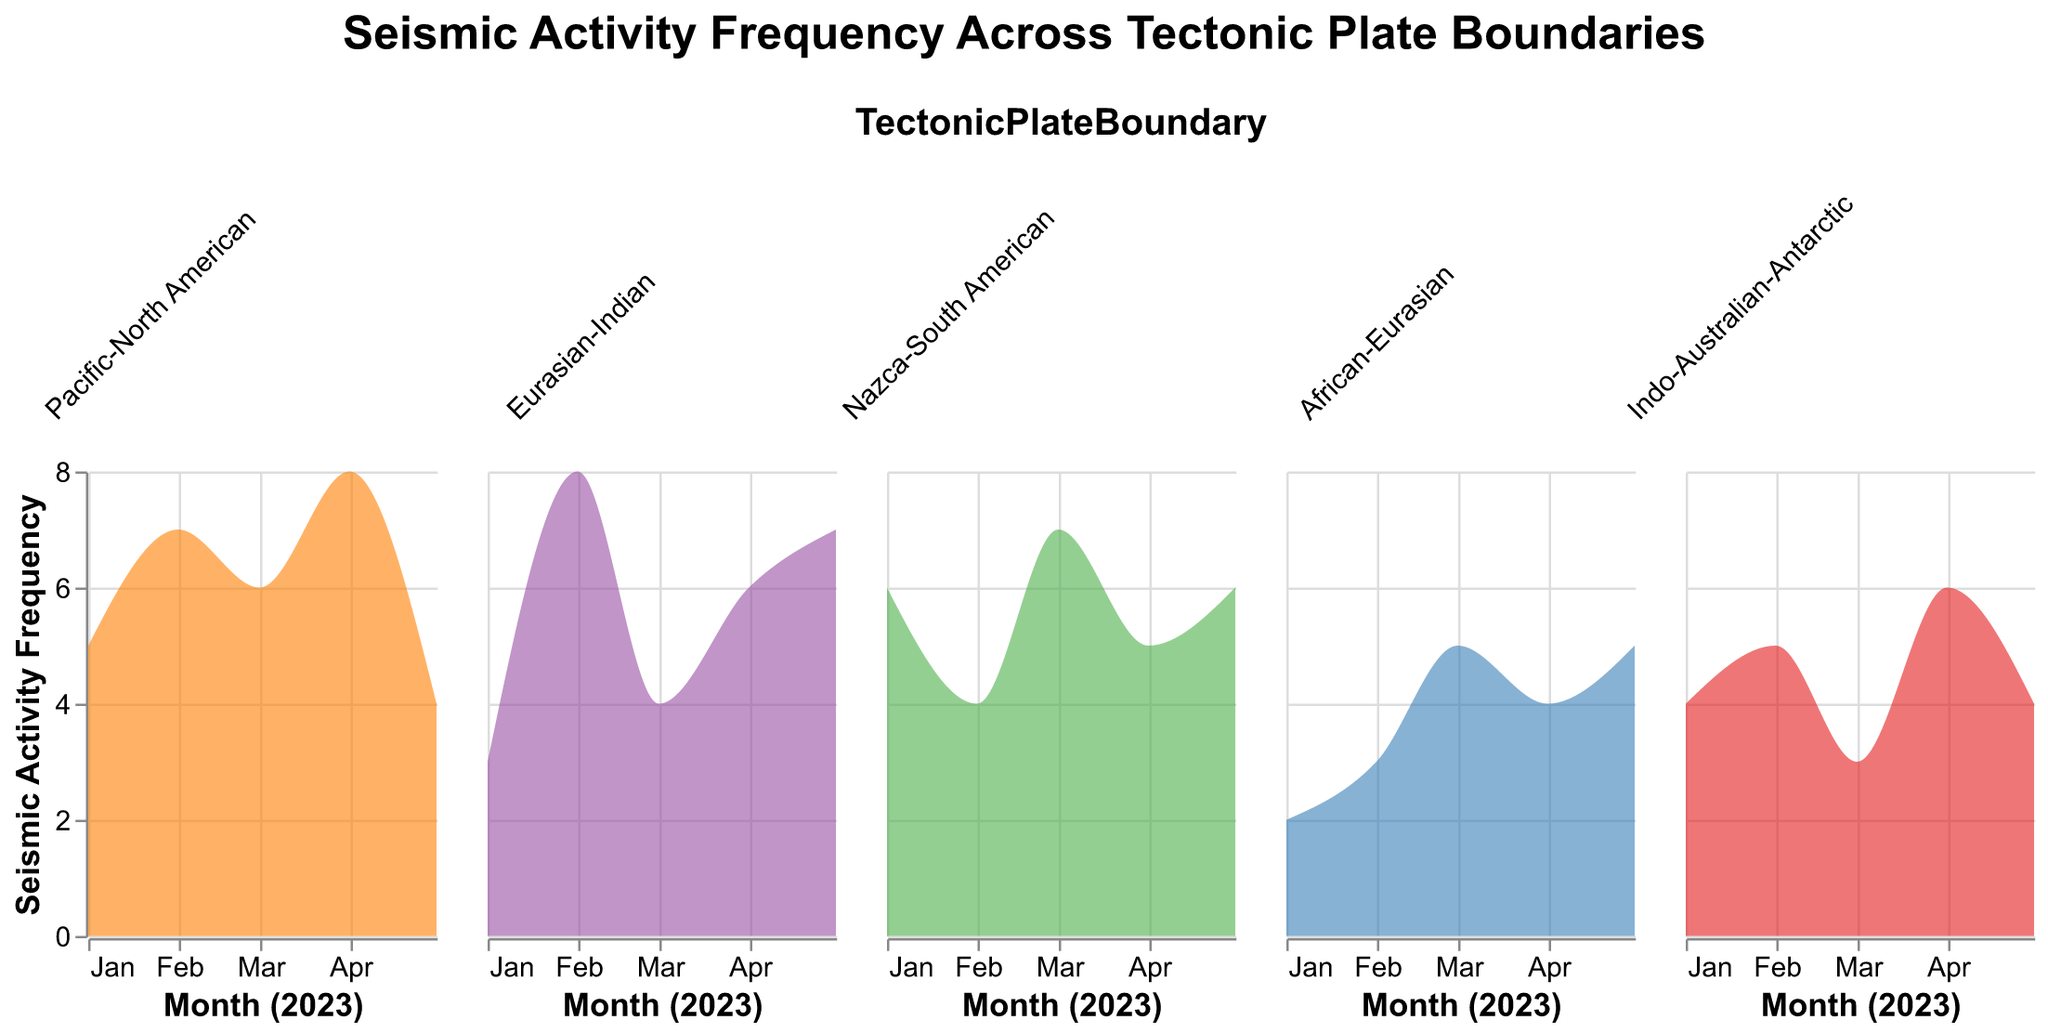What is the title of the plot? The title of the plot is centered and displayed at the top in large text. It reads, "Seismic Activity Frequency Across Tectonic Plate Boundaries".
Answer: Seismic Activity Frequency Across Tectonic Plate Boundaries Which tectonic plate boundary has the highest seismic activity frequency in January? By looking at the density plots for January, "Nazca-South American" shows the highest seismic activity frequency with a value of 6.
Answer: Nazca-South American What are the colors representing the different tectonic plate boundaries? The five colors used to represent the plate boundaries are identified by the legend: "Pacific-North American" is orange, "Eurasian-Indian" is purple, "Nazca-South American" is green, "African-Eurasian" is blue, and "Indo-Australian-Antarctic" is red.
Answer: Orange, Purple, Green, Blue, Red Which tectonic plate boundary shows the most variation in seismic activity frequency over the months? Observing the density plots, "Pacific-North American" has the most variation with frequencies ranging from 4 to 8 over different months.
Answer: Pacific-North American How does the seismic activity frequency change for the "Eurasian-Indian" boundary across the months shown? The graph shows that the seismic activity frequency for "Eurasian-Indian" is 3 in January, 8 in February, 4 in March, 6 in April, and 7 in May.
Answer: 3, 8, 4, 6, 7 Compare the seismic activity frequency in March and April for "Indo-Australian-Antarctic". Which month has higher frequency? The plot shows that "Indo-Australian-Antarctic" has a frequency of 3 in March and 6 in April, so April has a higher frequency.
Answer: April Which tectonic plate boundary experienced the lowest seismic activity frequency in the given time period? By examining the plot, "African-Eurasian" experienced the lowest seismic activity frequency with a value of 2 in January.
Answer: African-Eurasian What is the average seismic activity frequency for the "Pacific-North American" boundary over the months? The frequencies for "Pacific-North American" across the months are 5, 7, 6, 8, and 4. The sum is 30, and there are 5 months, so the average is 30/5.
Answer: 6 